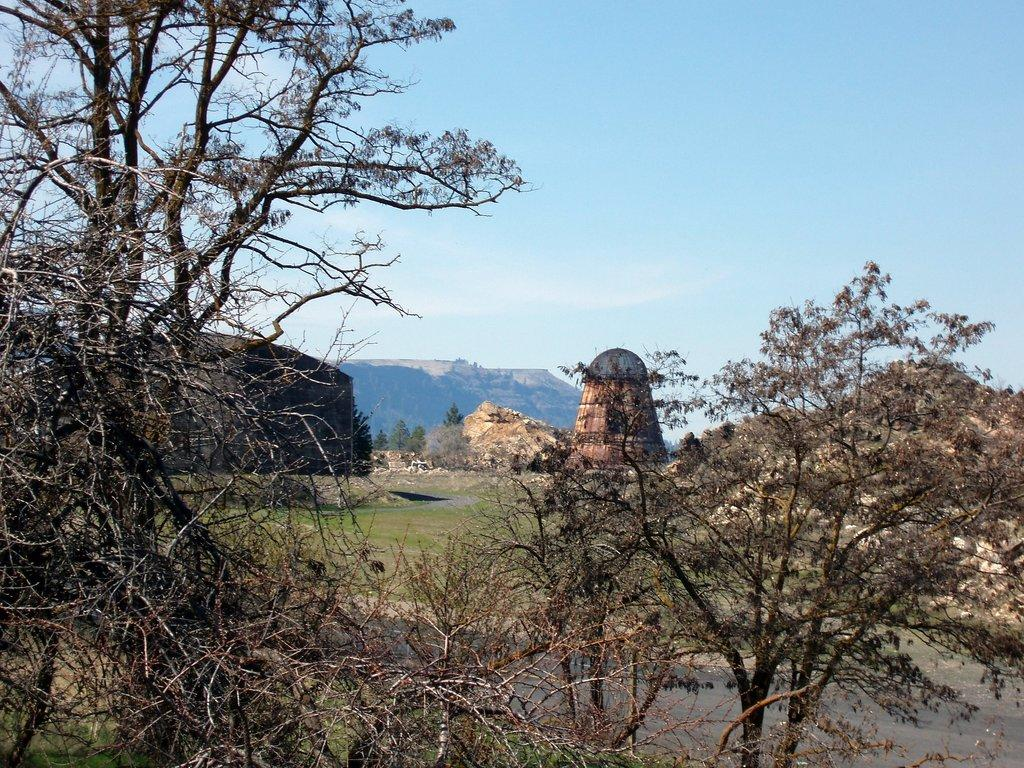What type of pathway is visible in the image? There is a road in the image. What type of vegetation can be seen in the image? There are trees and grass in the image. What type of natural feature is present in the image? There are rocks and a mountain in the image. What is visible in the background of the image? The sky is visible in the background of the image. How many rabbits can be seen hopping on the road in the image? There are no rabbits present in the image; it features a road, trees, grass, rocks, a mountain, and the sky. What type of reptile is slithering through the grass in the image? There are no snakes or any other reptiles present in the image; it features a road, trees, grass, rocks, a mountain, and the sky. 